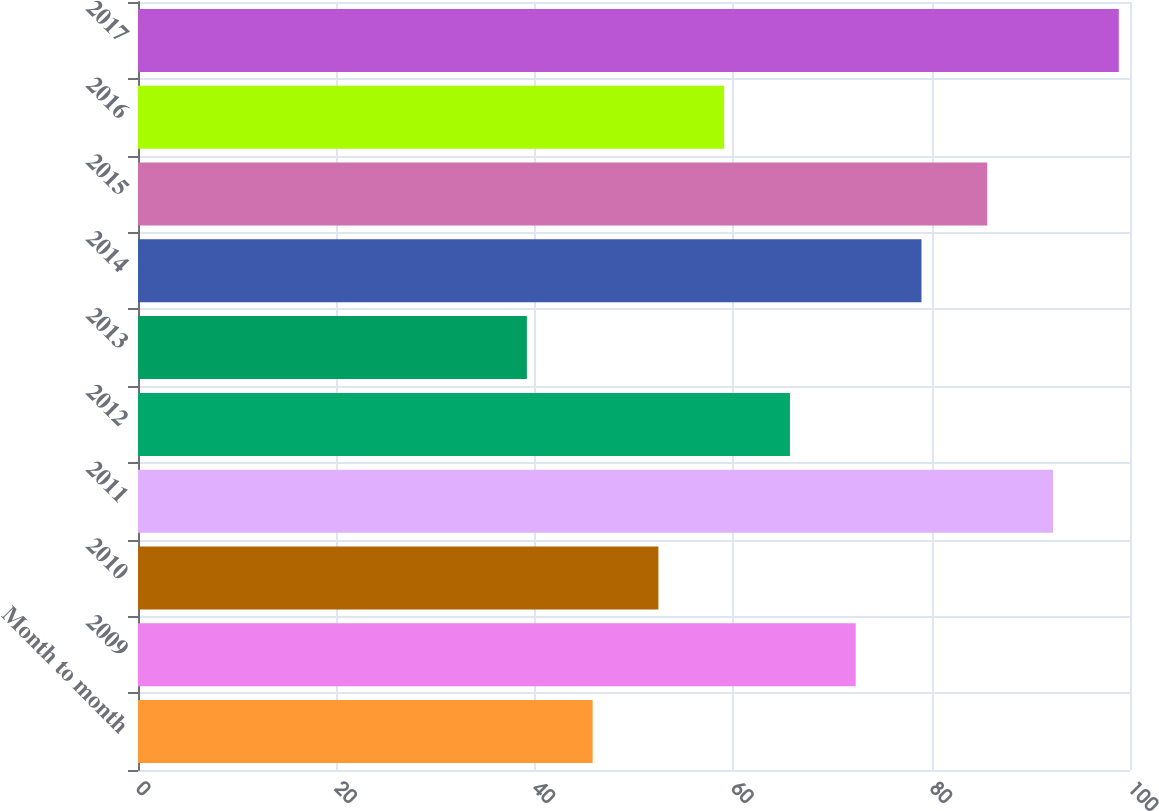Convert chart to OTSL. <chart><loc_0><loc_0><loc_500><loc_500><bar_chart><fcel>Month to month<fcel>2009<fcel>2010<fcel>2011<fcel>2012<fcel>2013<fcel>2014<fcel>2015<fcel>2016<fcel>2017<nl><fcel>45.83<fcel>72.35<fcel>52.46<fcel>92.24<fcel>65.72<fcel>39.2<fcel>78.98<fcel>85.61<fcel>59.09<fcel>98.87<nl></chart> 